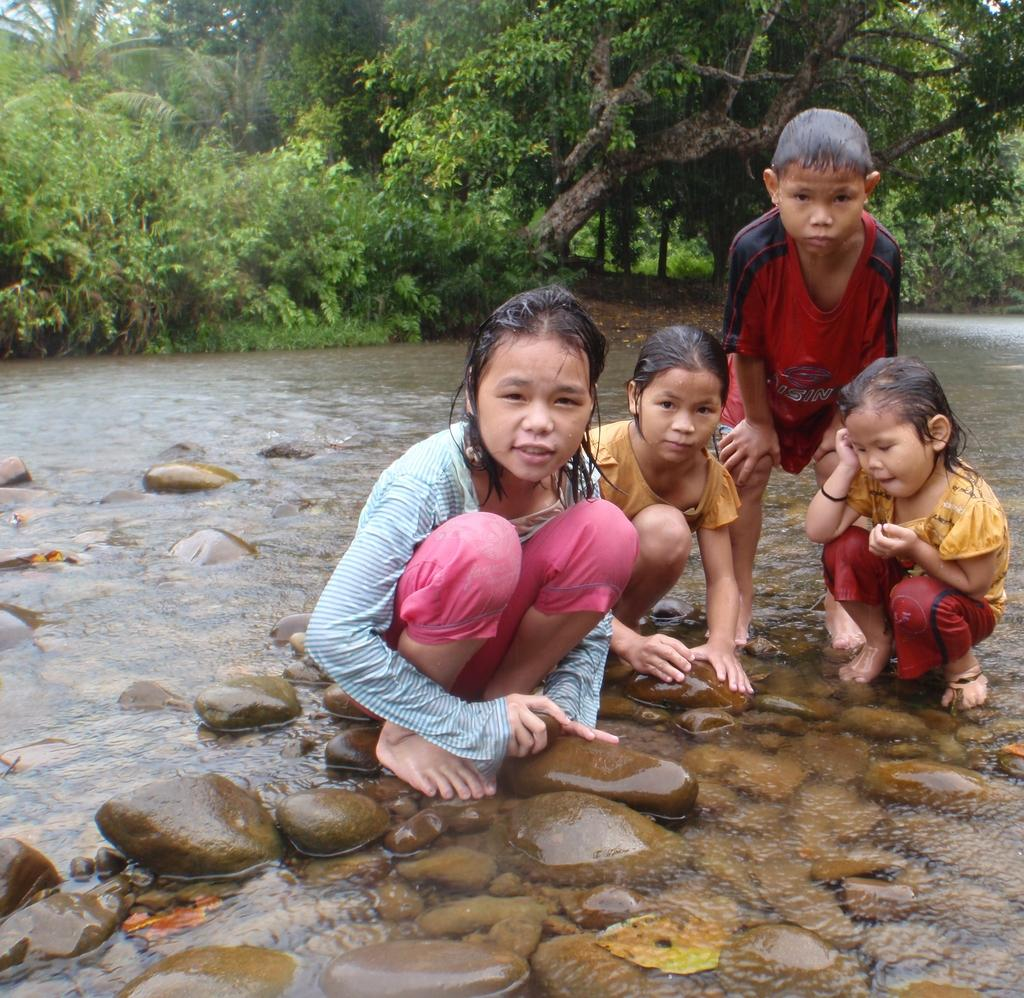What can be seen in the image? There are kids in the image. What are the kids doing in the image? The kids are crouching on stones. Where are the stones located? The stones are in water. What can be seen in the background of the image? There are trees in the background of the image. What type of meat is being cooked on the potato in the image? There is no meat or potato present in the image; it features kids crouching on stones in water with trees in the background. 